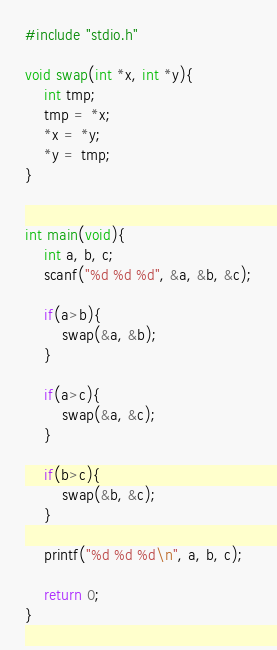<code> <loc_0><loc_0><loc_500><loc_500><_C_>#include "stdio.h"

void swap(int *x, int *y){
    int tmp;
    tmp = *x;
    *x = *y;
    *y = tmp;
}


int main(void){
    int a, b, c;
    scanf("%d %d %d", &a, &b, &c);
    
    if(a>b){
        swap(&a, &b);
    }
    
    if(a>c){
        swap(&a, &c);
    }
    
    if(b>c){
        swap(&b, &c);
    }
    
    printf("%d %d %d\n", a, b, c);
    
    return 0;
}</code> 